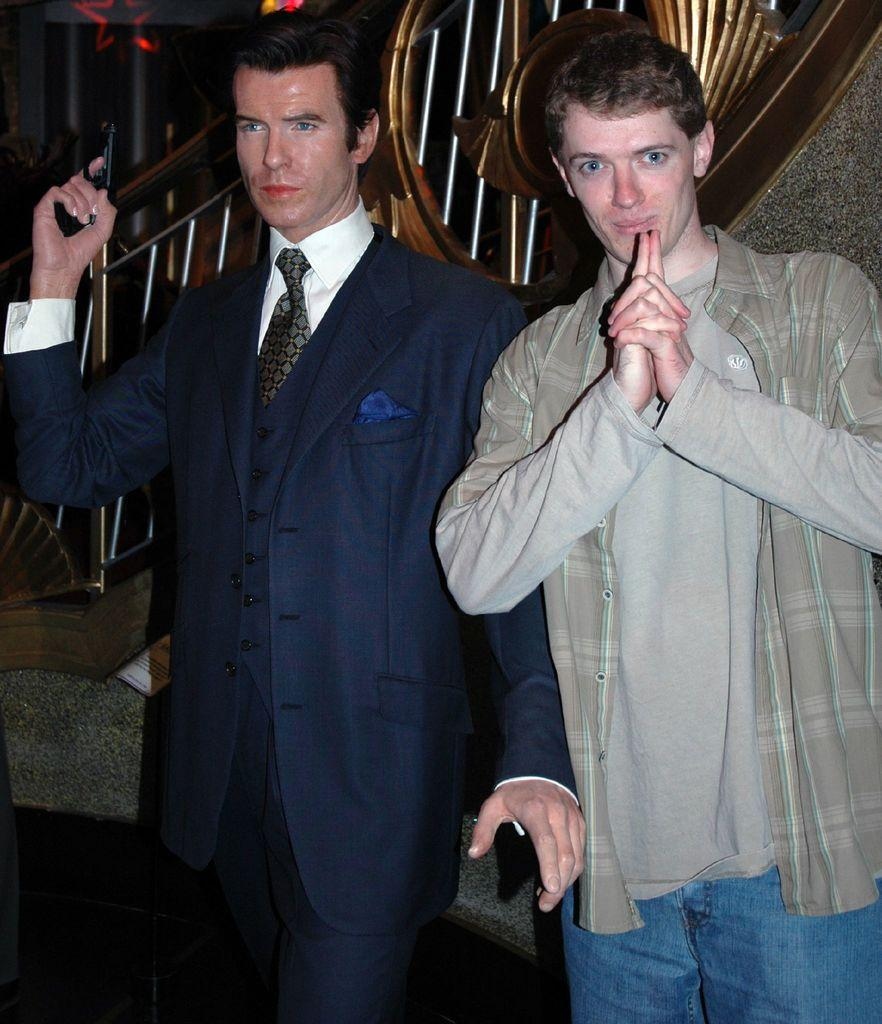How many people are in the image? There are two men standing in the image. What is one of the men holding? One of the men is holding a gun. What is the man with the gun wearing? The man with the gun is wearing a suitcase. What can be seen in the background of the image? There are steps in the background of the image. What is visible at the bottom of the image? There is a floor visible at the bottom of the image. What type of branch can be seen in the image? There is no branch present in the image. Is the judge in the image wearing a robe? There is no judge present in the image. 